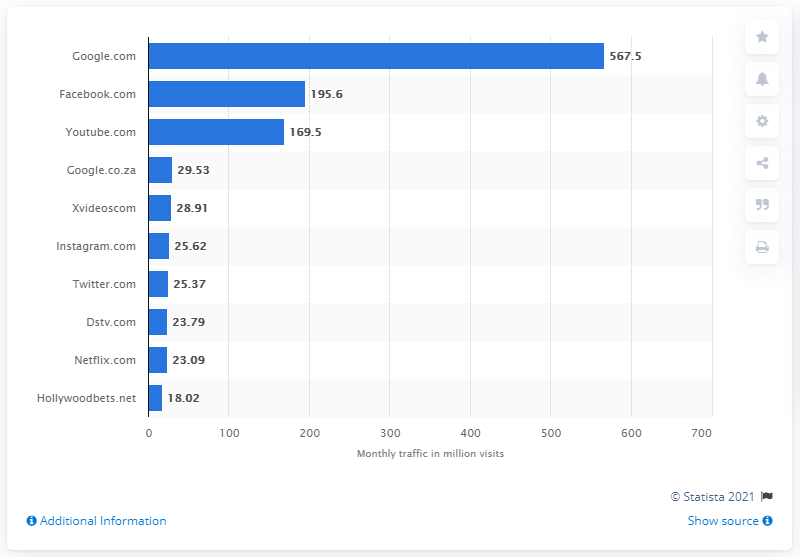Indicate a few pertinent items in this graphic. According to data available as of January 2020, Facebook.com ranked as the second most popular social platform in South Africa. As of January 2020, Google.com was the top-ranking website in South Africa. 